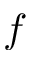<formula> <loc_0><loc_0><loc_500><loc_500>f</formula> 